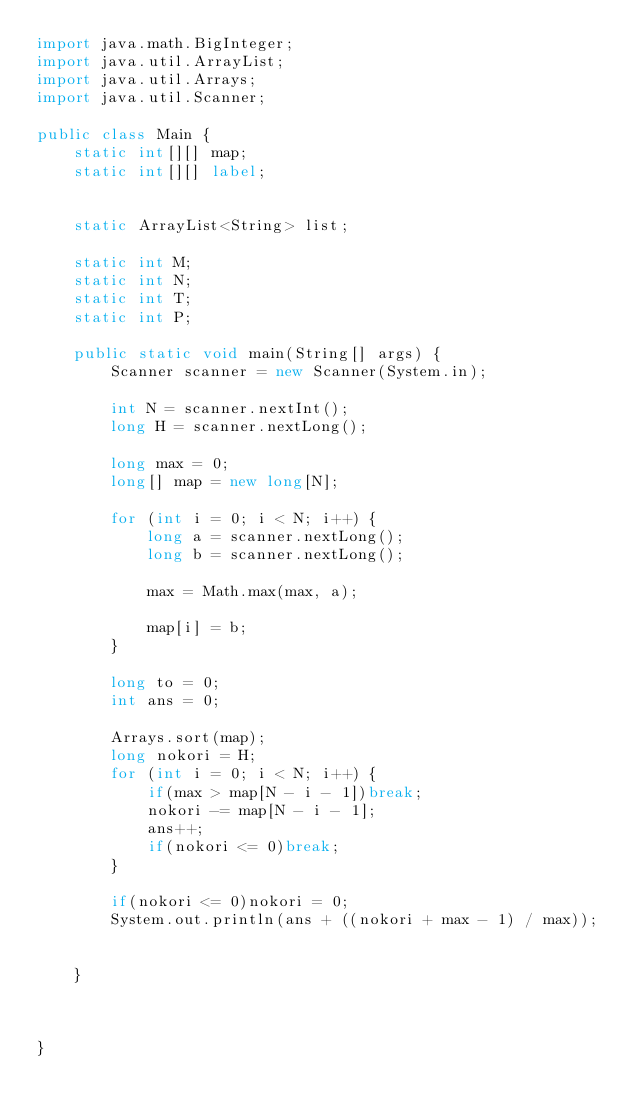Convert code to text. <code><loc_0><loc_0><loc_500><loc_500><_Java_>import java.math.BigInteger;
import java.util.ArrayList;
import java.util.Arrays;
import java.util.Scanner;

public class Main {
    static int[][] map;
    static int[][] label;


    static ArrayList<String> list;

    static int M;
    static int N;
    static int T;
    static int P;

    public static void main(String[] args) {
        Scanner scanner = new Scanner(System.in);

        int N = scanner.nextInt();
        long H = scanner.nextLong();

        long max = 0;
        long[] map = new long[N];

        for (int i = 0; i < N; i++) {
            long a = scanner.nextLong();
            long b = scanner.nextLong();

            max = Math.max(max, a);

            map[i] = b;
        }

        long to = 0;
        int ans = 0;

        Arrays.sort(map);
        long nokori = H;
        for (int i = 0; i < N; i++) {
            if(max > map[N - i - 1])break;
            nokori -= map[N - i - 1];
            ans++;
            if(nokori <= 0)break;
        }

        if(nokori <= 0)nokori = 0;
        System.out.println(ans + ((nokori + max - 1) / max));


    }



}
</code> 